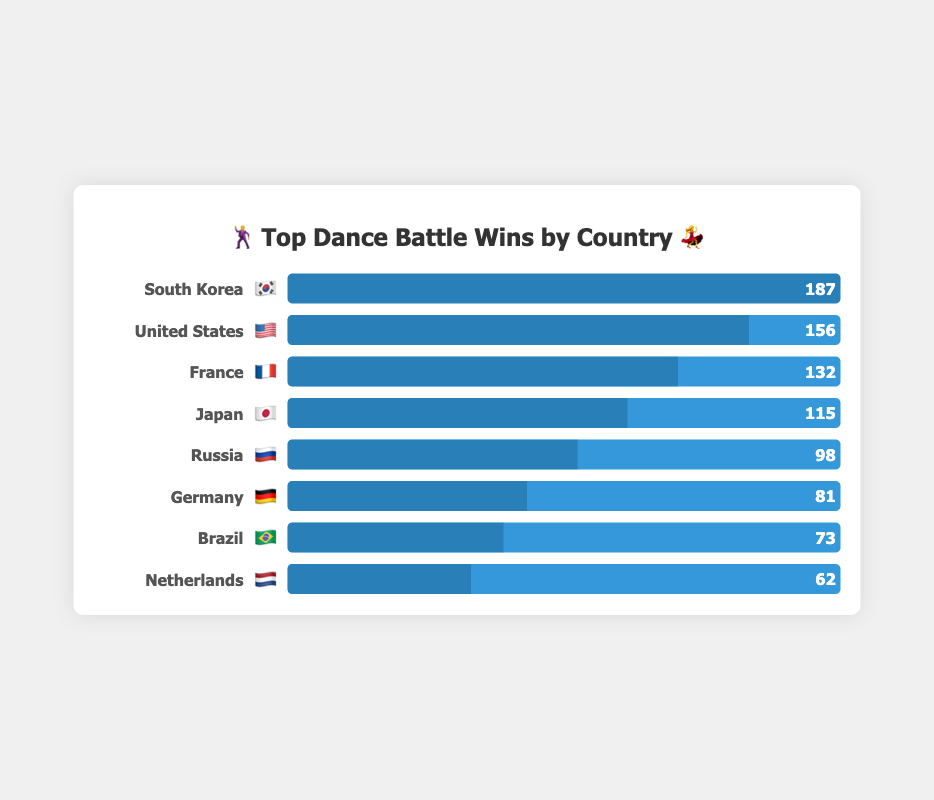What is the country with the most dance battle wins? The country with the most wins is the one with the longest bar in the chart. South Korea's bar is the longest with 187 wins.
Answer: South Korea 🇰🇷 How many countries are displayed in the chart? Count the number of distinct bars, each representing a country. There are 8 bars in the chart.
Answer: 8 Which countries have more than 100 dance battle wins? Identify the countries with bars longer than the corresponding 100 mark. South Korea, United States, France, and Japan all have more than 100 wins.
Answer: South Korea 🇰🇷, United States 🇺🇸, France 🇫🇷, Japan 🇯🇵 What's the difference in dance battle wins between South Korea and Russia? Subtract the number of wins for Russia from South Korea's wins: 187 - 98. This yields a difference of 89 wins.
Answer: 89 How many total wins do the top three countries have? Add the wins of the top three countries: South Korea (187), United States (156), and France (132): 187 + 156 + 132 = 475.
Answer: 475 Who has fewer wins, Germany or Brazil? Compare the lengths of the bars for Germany and Brazil. Germany has 81 wins, and Brazil has 73 wins. Brazil has fewer wins.
Answer: Brazil 🇧🇷 What's the average number of wins for all the countries shown? Add up all the wins and divide by the number of countries: (187 + 156 + 132 + 115 + 98 + 81 + 73 + 62) / 8 = 904 / 8 = 113.
Answer: 113 Which country is positioned just above Brazil in terms of wins? Look at the bar just above Brazil's 73 wins. Germany is just above Brazil with 81 wins.
Answer: Germany 🇩🇪 How much greater are the United States' wins compared to the Netherlands? Subtract the Netherlands' wins from the United States' wins: 156 - 62 = 94.
Answer: 94 